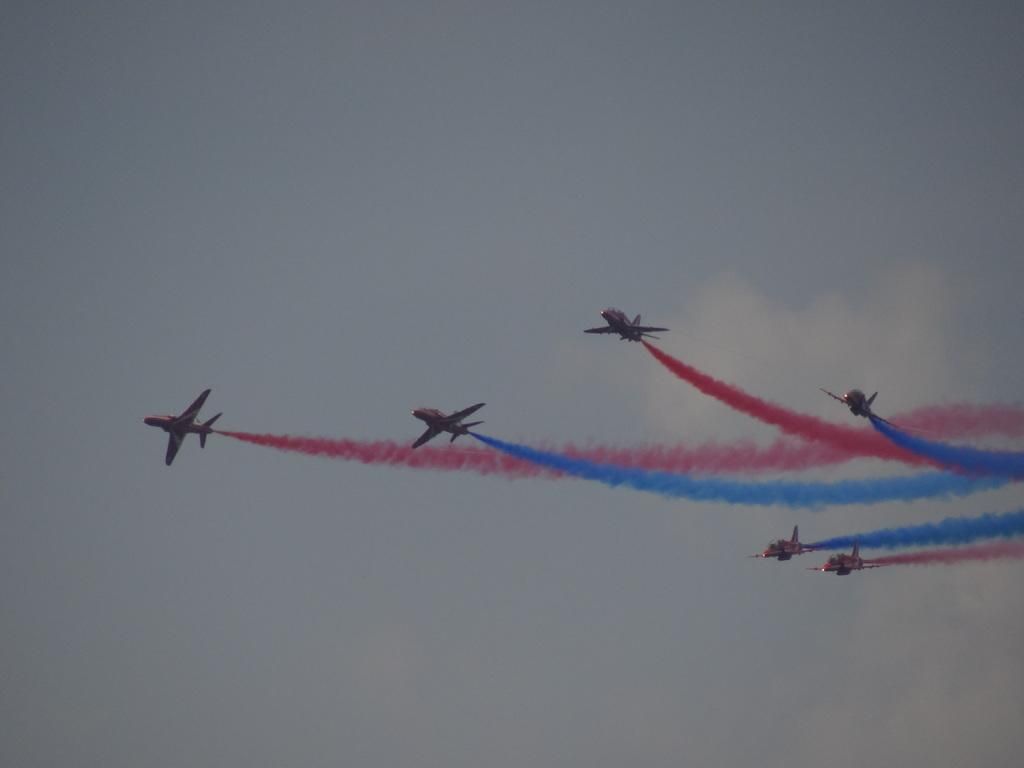What is the main subject of the image? The main subject of the image is airplanes. What can be seen in the air around the airplanes? There is smoke in the air. What is visible in the background of the image? The sky is visible in the image. What is the condition of the sky in the image? Clouds are present in the sky. What type of winter clothing is visible on the airplanes in the image? There is no winter clothing present on the airplanes in the image, as the focus is on the airplanes themselves and the smoke in the air. Can you tell me how many streams are flowing beneath the airplanes in the image? There are no streams visible in the image; the focus is on the airplanes, smoke, sky, and clouds. 